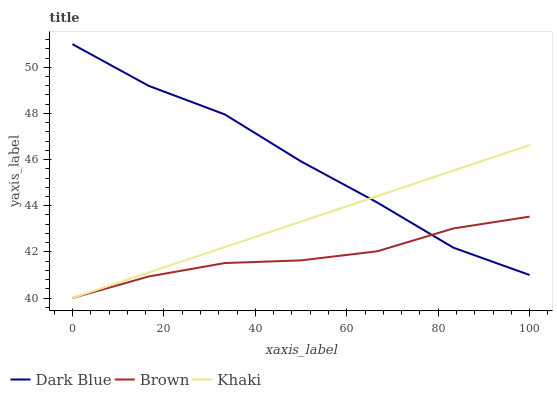Does Brown have the minimum area under the curve?
Answer yes or no. Yes. Does Dark Blue have the maximum area under the curve?
Answer yes or no. Yes. Does Khaki have the minimum area under the curve?
Answer yes or no. No. Does Khaki have the maximum area under the curve?
Answer yes or no. No. Is Khaki the smoothest?
Answer yes or no. Yes. Is Dark Blue the roughest?
Answer yes or no. Yes. Is Brown the smoothest?
Answer yes or no. No. Is Brown the roughest?
Answer yes or no. No. Does Khaki have the lowest value?
Answer yes or no. Yes. Does Dark Blue have the highest value?
Answer yes or no. Yes. Does Khaki have the highest value?
Answer yes or no. No. Does Brown intersect Dark Blue?
Answer yes or no. Yes. Is Brown less than Dark Blue?
Answer yes or no. No. Is Brown greater than Dark Blue?
Answer yes or no. No. 